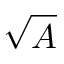Convert formula to latex. <formula><loc_0><loc_0><loc_500><loc_500>\sqrt { A }</formula> 